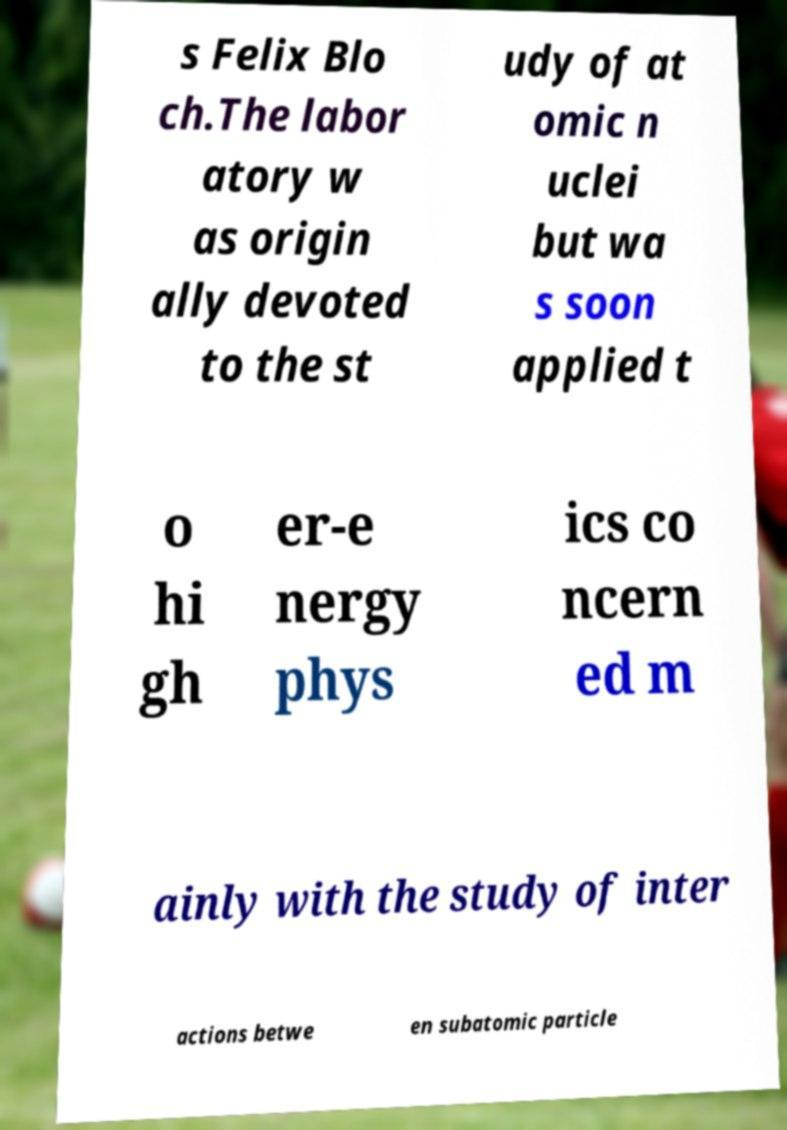Please read and relay the text visible in this image. What does it say? s Felix Blo ch.The labor atory w as origin ally devoted to the st udy of at omic n uclei but wa s soon applied t o hi gh er-e nergy phys ics co ncern ed m ainly with the study of inter actions betwe en subatomic particle 